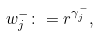Convert formula to latex. <formula><loc_0><loc_0><loc_500><loc_500>w _ { j } ^ { - } \colon = r ^ { \gamma _ { j } ^ { - } } ,</formula> 